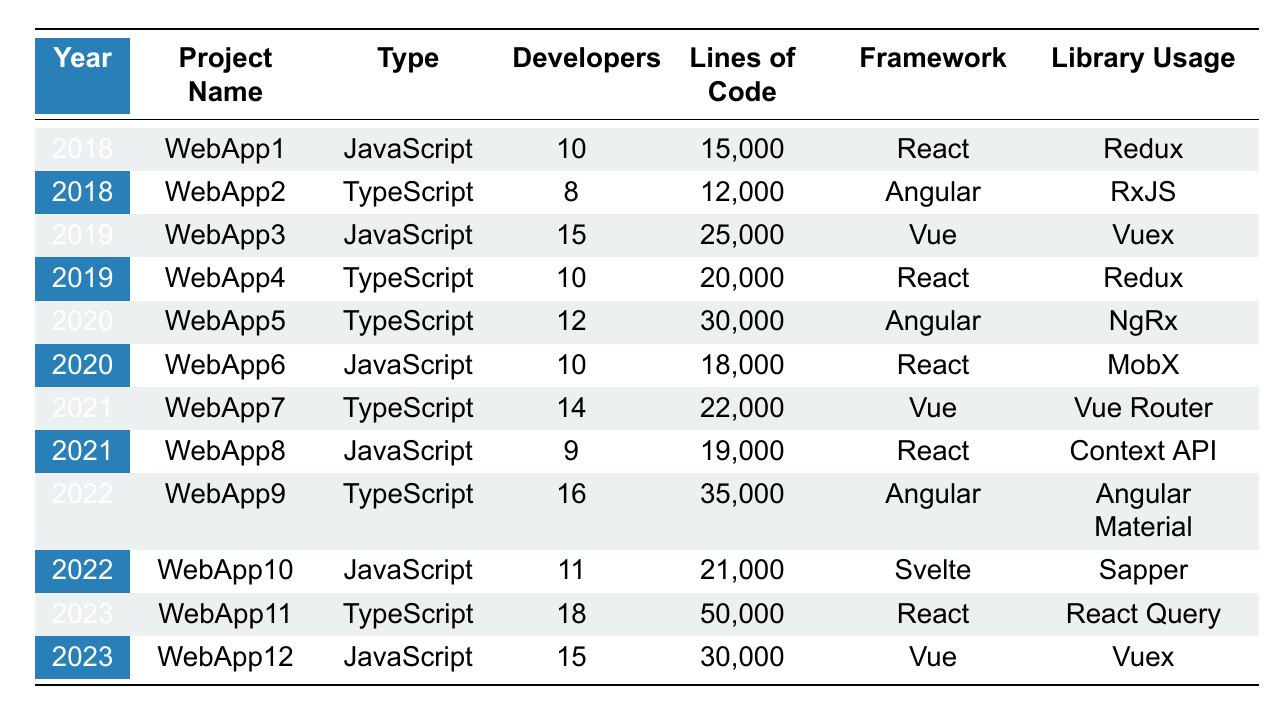What was the total number of developers working on JavaScript projects in 2020? In 2020, there are two JavaScript projects. The developers are 10 from WebApp6 and 10 from WebApp5. Adding them together gives 10 + 10 = 20 developers.
Answer: 20 Which project had the highest lines of code in 2023? In 2023, WebApp11 has 50,000 lines of code, which is more than WebApp12, which has 30,000 lines. Thus, WebApp11 is the project with the highest lines of code.
Answer: WebApp11 Is there any project from 2022 that used Vue framework and was developed using TypeScript? In 2022, all projects using TypeScript were WebApp9, which used Angular. There were no TypeScript projects using the Vue framework in 2022.
Answer: No What is the average number of developers across all TypeScript projects listed in the table? The TypeScript projects have the following developers: 8 (WebApp2), 10 (WebApp4), 12 (WebApp5), 14 (WebApp7), 16 (WebApp9), and 18 (WebApp11). Summing these gives 8 + 10 + 12 + 14 + 16 + 18 = 78. There are 6 projects, so the average is 78 / 6 = 13.
Answer: 13 Which year had more TypeScript projects than JavaScript projects? Analyzing each year: 2018 (1 TypeScript, 1 JavaScript), 2019 (1 TypeScript, 1 JavaScript), 2020 (1 TypeScript, 1 JavaScript), 2021 (1 TypeScript, 1 JavaScript), 2022 (1 TypeScript, 1 JavaScript), 2023 (1 TypeScript, 1 JavaScript). No year had more TypeScript projects.
Answer: No How has the total number of lines of code in TypeScript projects changed from 2018 to 2023? The lines of code for TypeScript projects are: 12,000 (2018), 20,000 (2019), 30,000 (2020), 22,000 (2021), 35,000 (2022), and 50,000 (2023). Adding these gives 12,000 + 20,000 + 30,000 + 22,000 + 35,000 + 50,000 = 169,000 lines.
Answer: 169,000 Which project in 2019 had a larger number of developers, and what is the difference in developers compared to the other project? In 2019, WebApp3 (JavaScript) had 15 developers and WebApp4 (TypeScript) had 10 developers. The difference is 15 - 10 = 5 developers.
Answer: 5 Did any JavaScript project have more than 20,000 lines of code in 2022? In 2022, there was one JavaScript project (WebApp10) with 21,000 lines of code, which is above 20,000.
Answer: Yes What framework was most commonly used in TypeScript projects from 2018 to 2023? By analyzing the frameworks: Angular was used in 2018 (1 project), 2020 (1 project), and 2022 (1 project), React was used in 2019 (1 project) and 2023 (1 project), and Vue was used in 2021 (1 project). Angular is the most common framework with 3 uses.
Answer: Angular Calculate the total number of developers for all projects in 2021 and state if this number is even or odd. In 2021, WebApp7 had 14 developers and WebApp8 had 9 developers, giving a total of 14 + 9 = 23 developers. Since 23 is an odd number, the answer is odd.
Answer: Odd What percentage of WebApp11's lines of code is larger than the total lines of code for TypeScript projects in 2020? WebApp11 has 50,000 lines of code, while WebApp5 in 2020 has 30,000 lines. The percentage is calculated by (50,000 - 30,000) / 30,000 * 100 = 66.67%.
Answer: 66.67% 